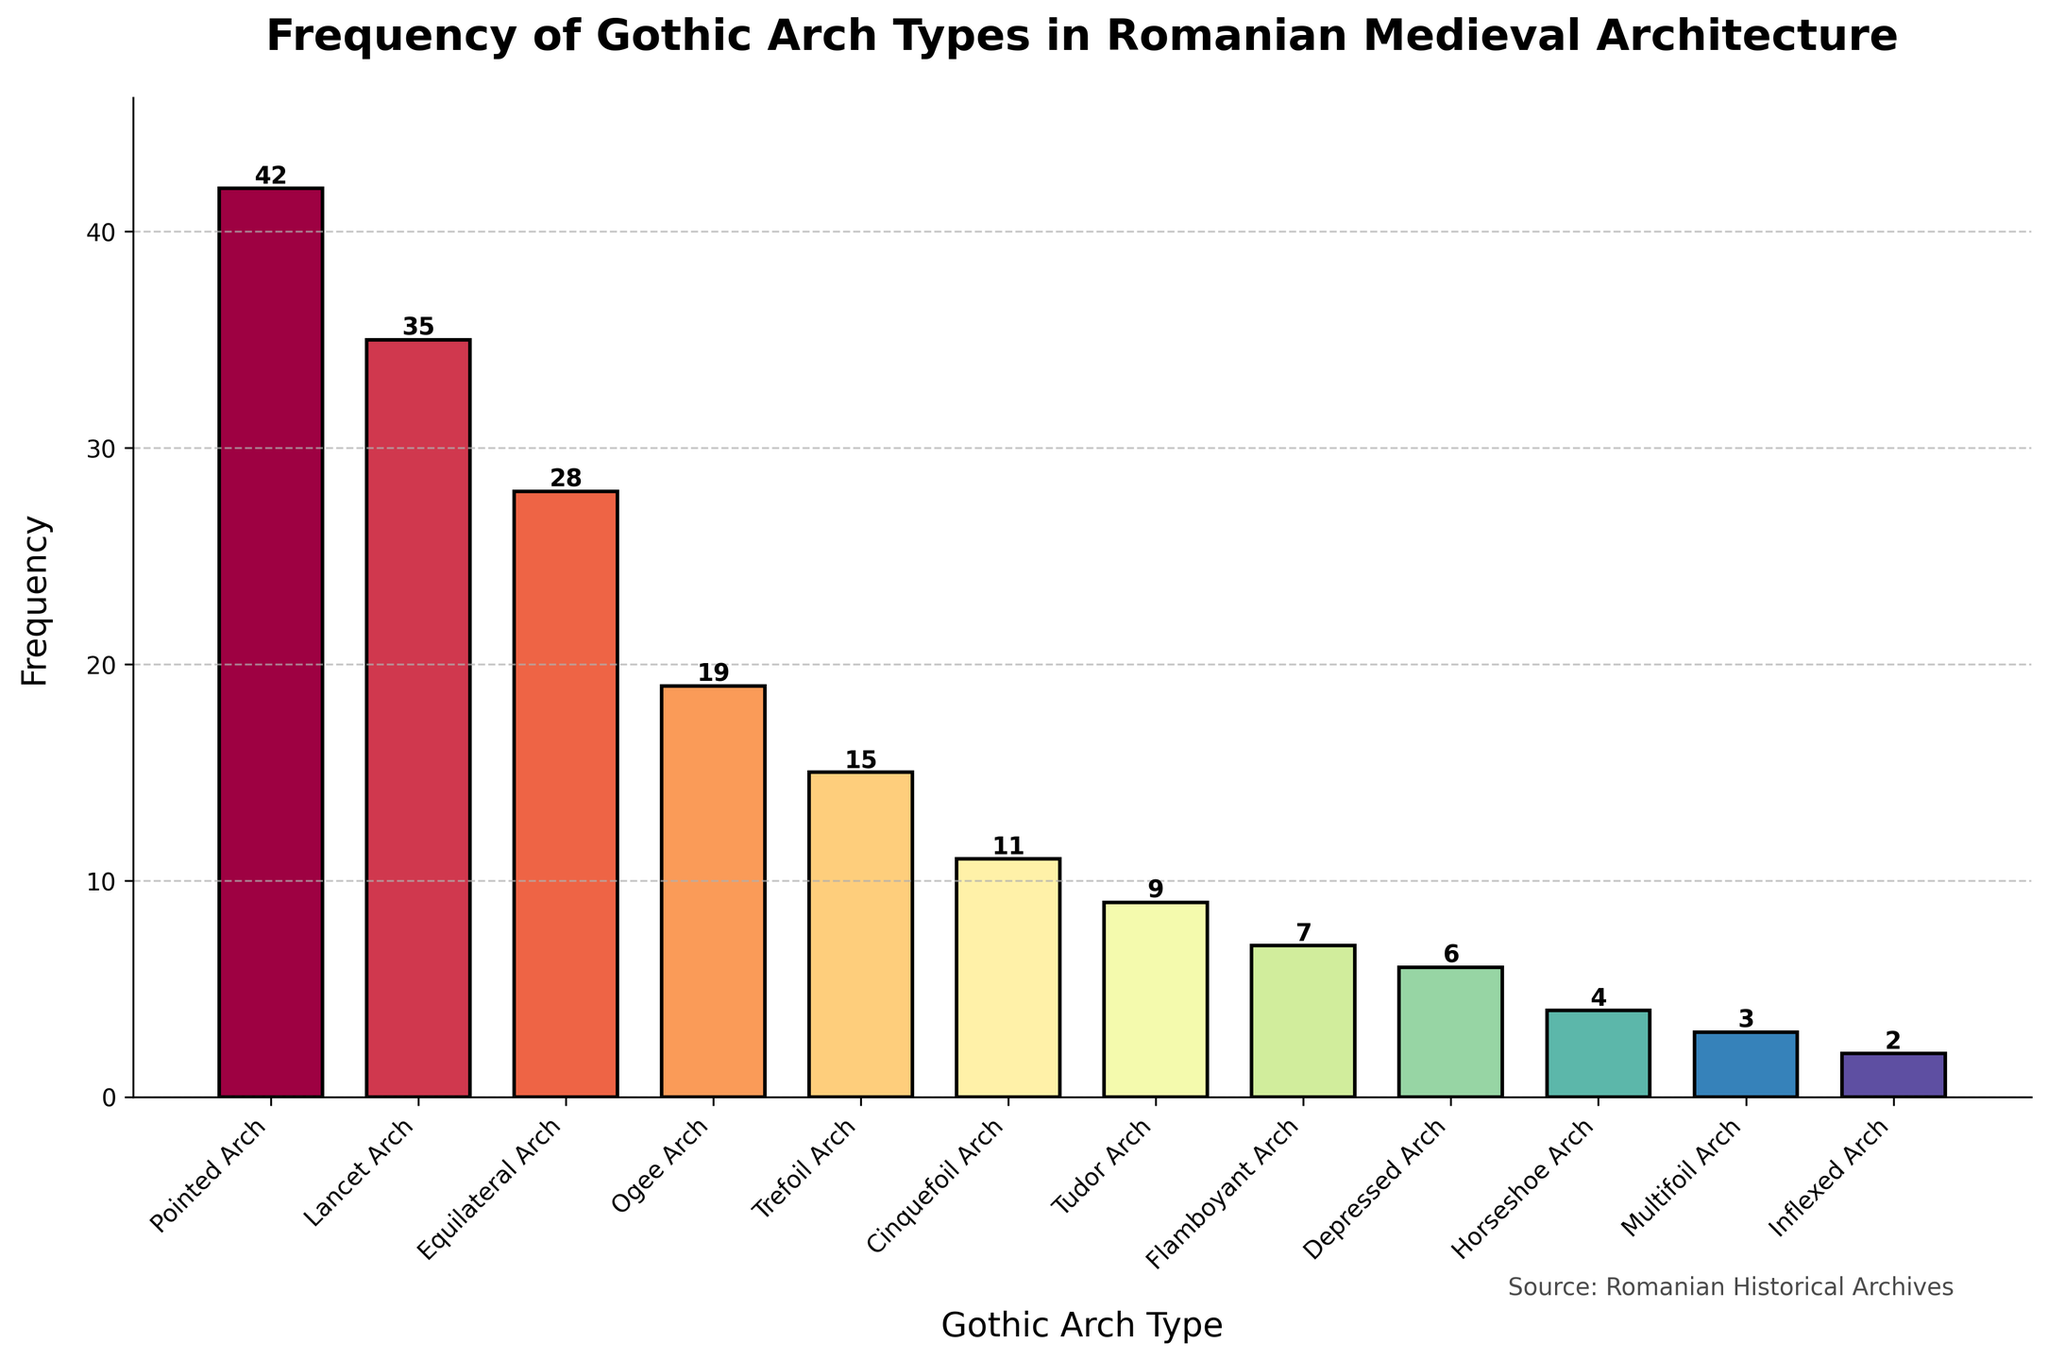Which Gothic arch type is used most frequently in Romanian medieval architecture? By looking at the heights of the bars, the tallest bar represents the "Pointed Arch," indicating that it has the highest frequency.
Answer: Pointed Arch How many more times is the Lancet Arch used compared to the Tudor Arch? The frequency of the Lancet Arch is 35 and the Tudor Arch is 9. Subtracting the two values, 35 - 9 = 26.
Answer: 26 What is the total number of occurrences for all the Gothic arch types combined? Adding up the frequencies: 42 + 35 + 28 + 19 + 15 + 11 + 9 + 7 + 6 + 4 + 3 + 2 = 181.
Answer: 181 Which Gothic arch type has the least frequency, and how many times is it used? The shortest bar represents "Inflexed Arch" with a frequency of 2.
Answer: Inflexed Arch, 2 Which type of Gothic arch is used exactly 3 times? The height of the bar labeled "Multifoil Arch" indicates a frequency of 3.
Answer: Multifoil Arch Is the frequency of using the Equilateral Arch greater than the Trefoil Arch? The frequency of the Equilateral Arch is 28, and the Trefoil Arch is 15. Since 28 is greater than 15, the answer is yes.
Answer: Yes What is the difference in frequency between the Ogee Arch and the Flamboyant Arch? Subtracting the frequency of the Flamboyant Arch (7) from the Ogee Arch (19): 19 - 7 = 12.
Answer: 12 How many Gothic arch types have a frequency of 10 or less? By looking at the plot, the arches with frequencies 11, 9, 7, 6, 4, 3, and 2 fall into this category, resulting in 7 types.
Answer: 7 What is the average frequency of the top three most frequently used Gothic arches? The top three frequencies are 42 (Pointed Arch), 35 (Lancet Arch), and 28 (Equilateral Arch). Adding these gives 42 + 35 + 28 = 105, and dividing by 3 results in an average of 105 / 3 = 35.
Answer: 35 Which Gothic arch types have a frequency that is less than the average frequency of the Equilateral, Lancet, and Pointed arches? The average frequency of the three most frequently used arches is 35. The types with frequencies less than this average are Equilateral Arch, Ogee Arch, Trefoil Arch, Cinquefoil Arch, Tudor Arch, Flamboyant Arch, Depressed Arch, Horseshoe Arch, Multifoil Arch, and Inflexed Arch.
Answer: 10 